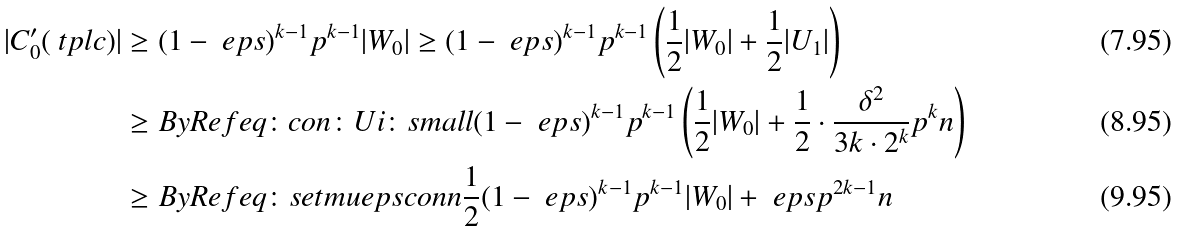<formula> <loc_0><loc_0><loc_500><loc_500>| C ^ { \prime } _ { 0 } ( \ t p l { c } ) | & \geq ( 1 - \ e p s ) ^ { k - 1 } p ^ { k - 1 } | W _ { 0 } | \geq ( 1 - \ e p s ) ^ { k - 1 } p ^ { k - 1 } \left ( \frac { 1 } { 2 } | W _ { 0 } | + \frac { 1 } { 2 } | U _ { 1 } | \right ) \\ & \geq B y R e f { e q \colon c o n \colon U i \colon s m a l l } ( 1 - \ e p s ) ^ { k - 1 } p ^ { k - 1 } \left ( \frac { 1 } { 2 } | W _ { 0 } | + \frac { 1 } { 2 } \cdot \frac { \delta ^ { 2 } } { 3 k \cdot 2 ^ { k } } p ^ { k } n \right ) \\ & \geq B y R e f { e q \colon s e t m u e p s c o n n } \frac { 1 } { 2 } ( 1 - \ e p s ) ^ { k - 1 } p ^ { k - 1 } | W _ { 0 } | + \ e p s p ^ { 2 k - 1 } n</formula> 